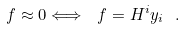Convert formula to latex. <formula><loc_0><loc_0><loc_500><loc_500>f \approx 0 \Longleftrightarrow \ f = H ^ { i } y _ { i } \ .</formula> 